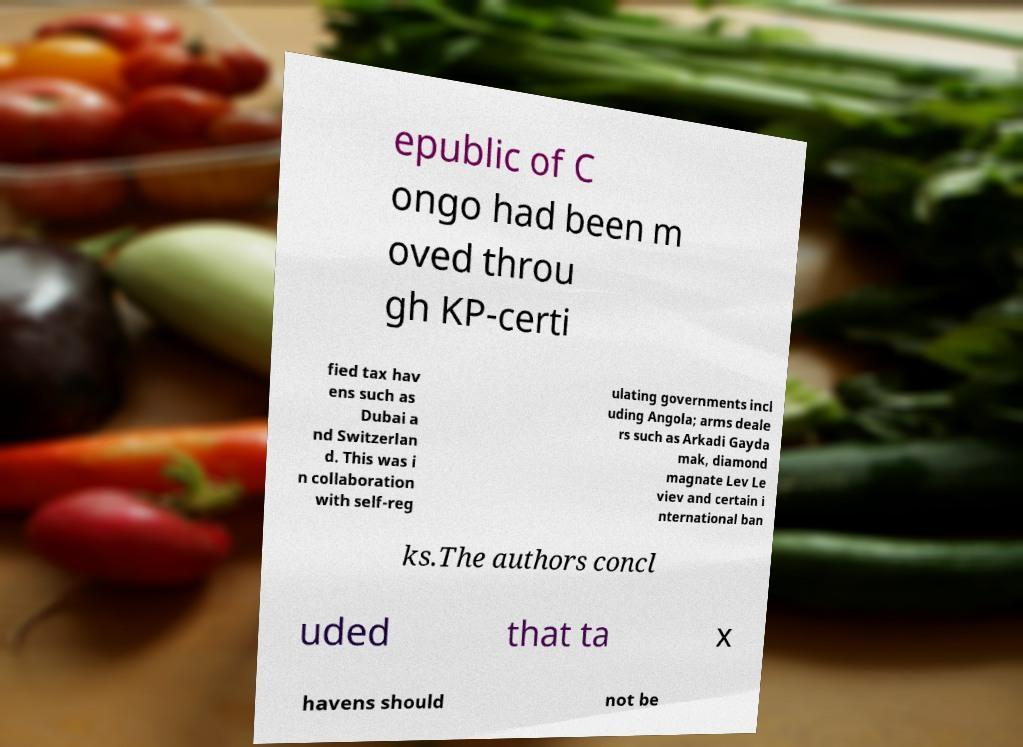Can you accurately transcribe the text from the provided image for me? epublic of C ongo had been m oved throu gh KP-certi fied tax hav ens such as Dubai a nd Switzerlan d. This was i n collaboration with self-reg ulating governments incl uding Angola; arms deale rs such as Arkadi Gayda mak, diamond magnate Lev Le viev and certain i nternational ban ks.The authors concl uded that ta x havens should not be 